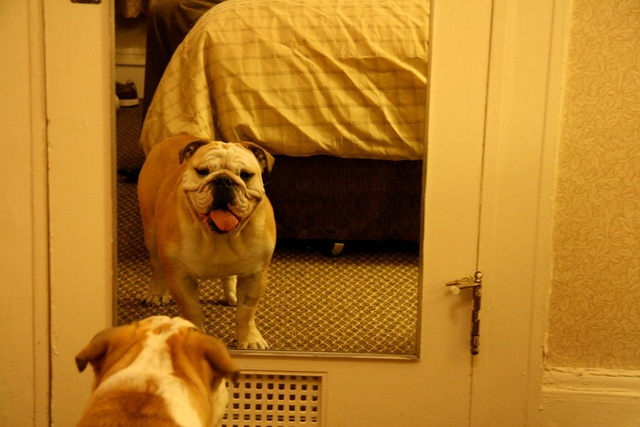Describe the objects in this image and their specific colors. I can see bed in orange, olive, and maroon tones and dog in orange, brown, and maroon tones in this image. 